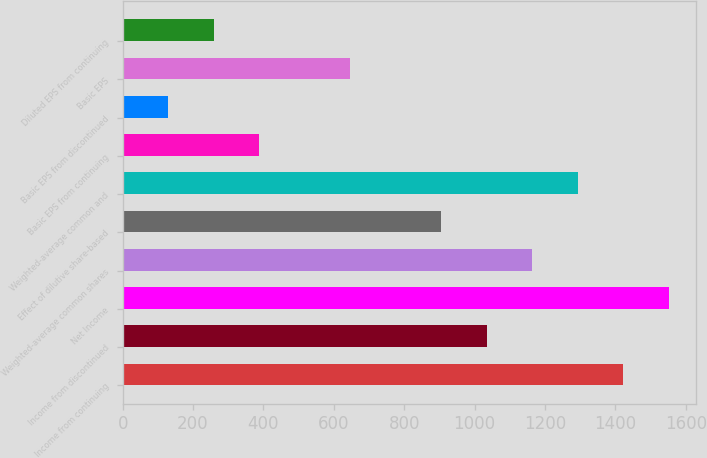Convert chart. <chart><loc_0><loc_0><loc_500><loc_500><bar_chart><fcel>Income from continuing<fcel>Income from discontinued<fcel>Net Income<fcel>Weighted-average common shares<fcel>Effect of dilutive share-based<fcel>Weighted-average common and<fcel>Basic EPS from continuing<fcel>Basic EPS from discontinued<fcel>Basic EPS<fcel>Diluted EPS from continuing<nl><fcel>1422.23<fcel>1034.57<fcel>1551.45<fcel>1163.79<fcel>905.35<fcel>1293.01<fcel>388.47<fcel>130.03<fcel>646.91<fcel>259.25<nl></chart> 